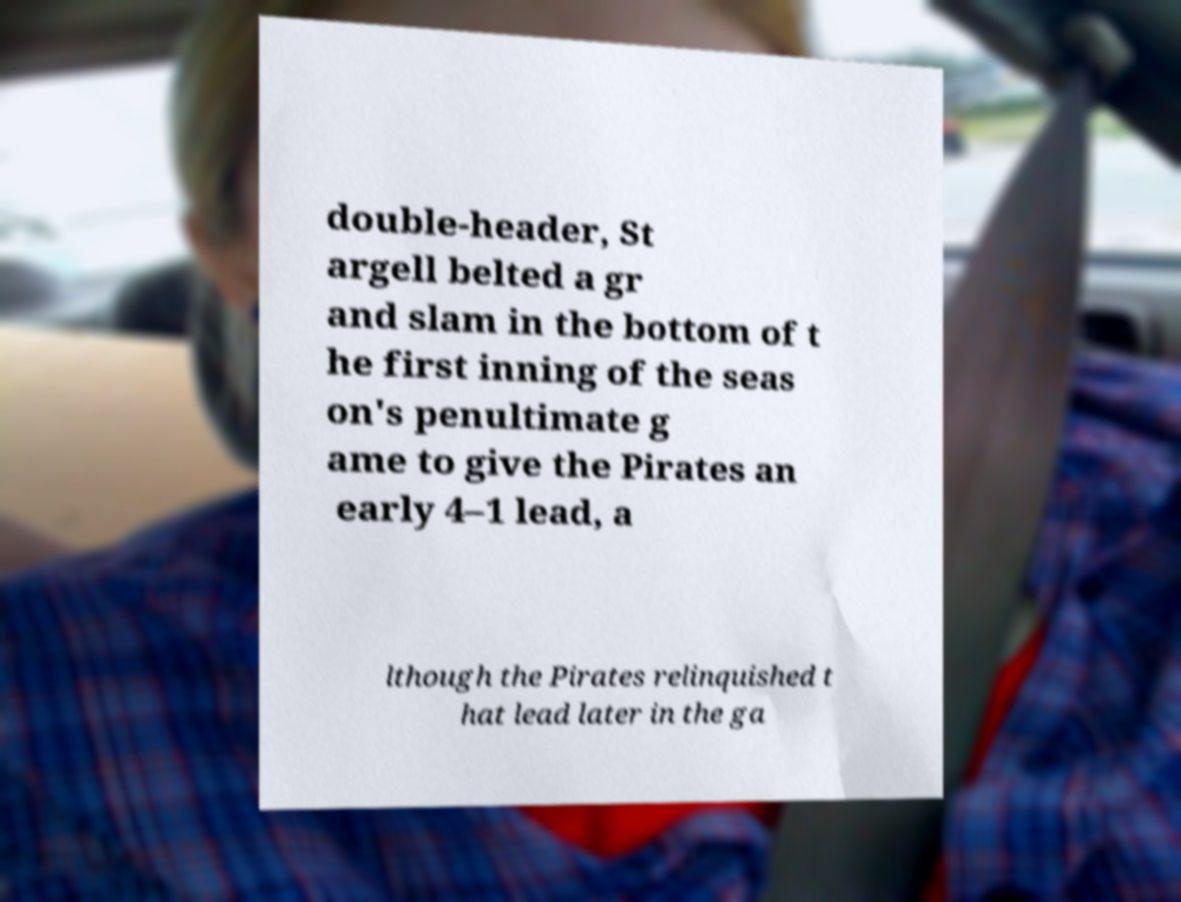For documentation purposes, I need the text within this image transcribed. Could you provide that? double-header, St argell belted a gr and slam in the bottom of t he first inning of the seas on's penultimate g ame to give the Pirates an early 4–1 lead, a lthough the Pirates relinquished t hat lead later in the ga 